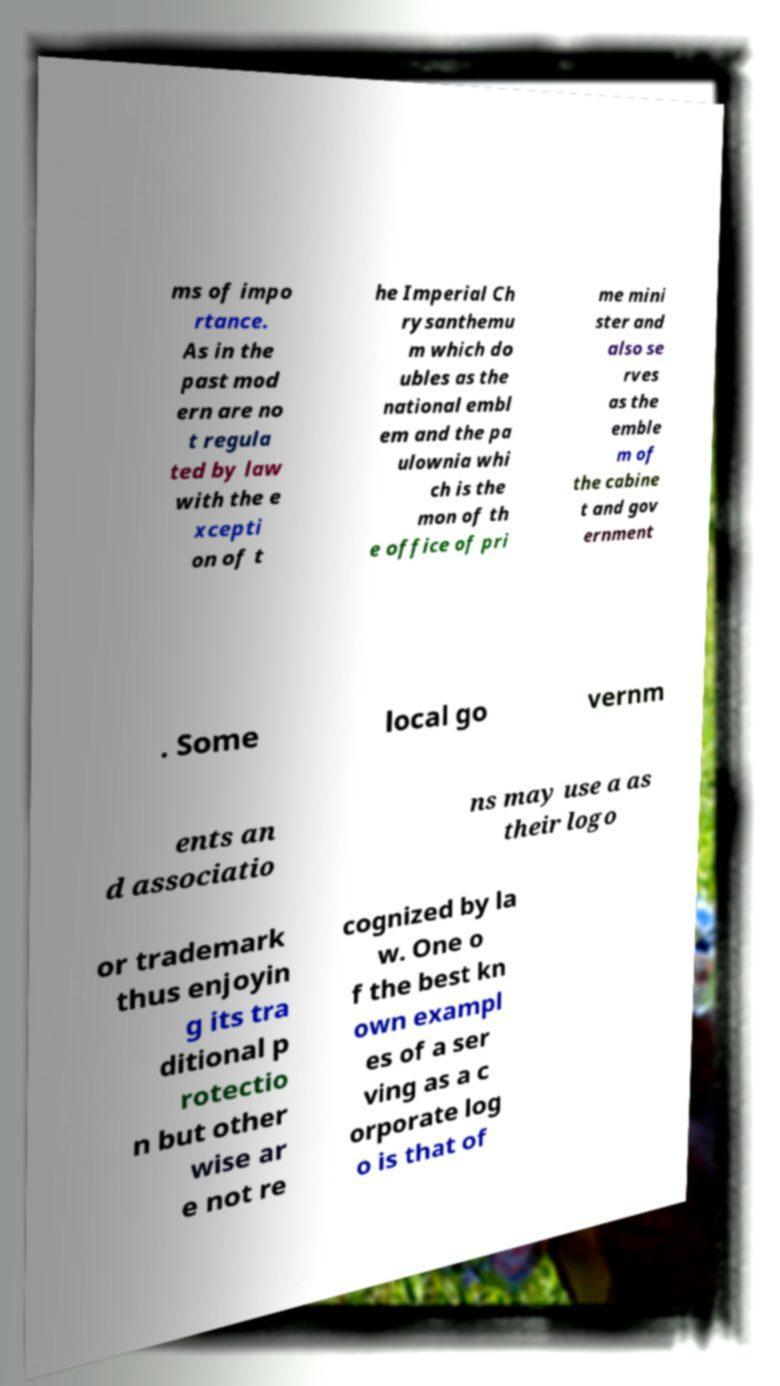Please identify and transcribe the text found in this image. ms of impo rtance. As in the past mod ern are no t regula ted by law with the e xcepti on of t he Imperial Ch rysanthemu m which do ubles as the national embl em and the pa ulownia whi ch is the mon of th e office of pri me mini ster and also se rves as the emble m of the cabine t and gov ernment . Some local go vernm ents an d associatio ns may use a as their logo or trademark thus enjoyin g its tra ditional p rotectio n but other wise ar e not re cognized by la w. One o f the best kn own exampl es of a ser ving as a c orporate log o is that of 